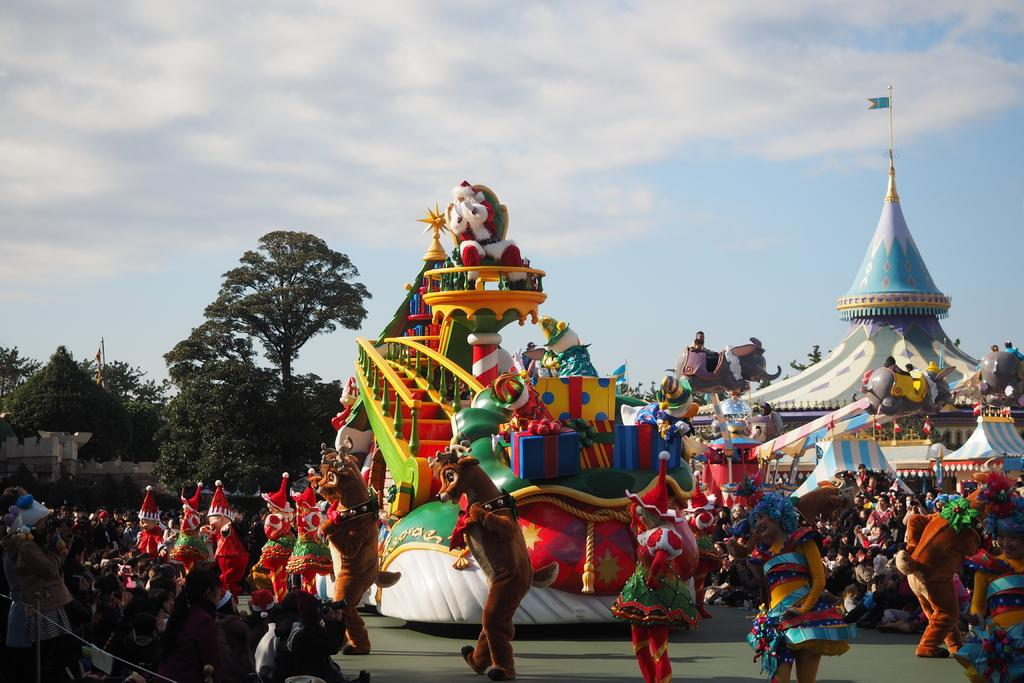What type of objects can be seen in the image? There are toys in the image. Who or what else is present in the image? There are people in the image. What other elements can be seen in the image besides the toys and people? There are trees and other objects in the image. What can be seen in the background of the image? The sky is visible in the background of the image. What type of button is being used by the mom in the image? There is no mom present in the image, and therefore no button usage can be observed. What type of rail is visible in the image? There is no rail present in the image. 